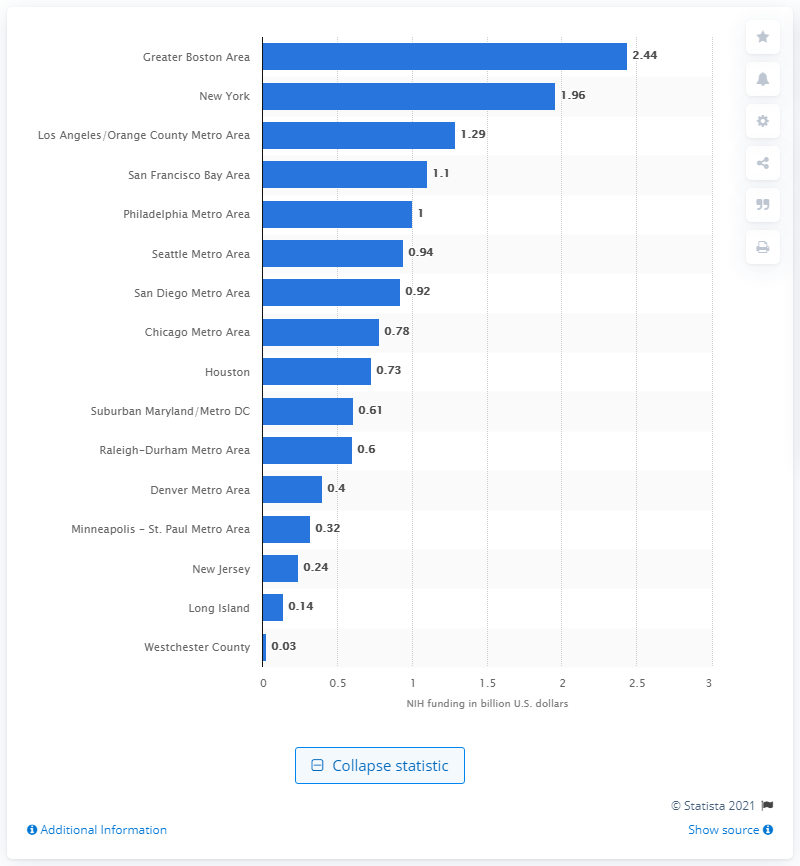Highlight a few significant elements in this photo. The Raleigh-Durham Metro Area received $0.6 million in funding from the National Institute of Health in 2018. 